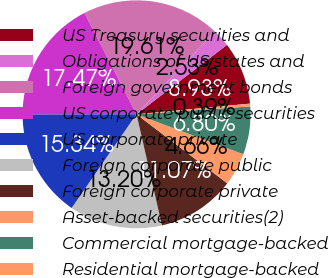Convert chart. <chart><loc_0><loc_0><loc_500><loc_500><pie_chart><fcel>US Treasury securities and<fcel>Obligations of US states and<fcel>Foreign government bonds<fcel>US corporate public securities<fcel>US corporate private<fcel>Foreign corporate public<fcel>Foreign corporate private<fcel>Asset-backed securities(2)<fcel>Commercial mortgage-backed<fcel>Residential mortgage-backed<nl><fcel>8.93%<fcel>2.53%<fcel>19.61%<fcel>17.47%<fcel>15.34%<fcel>13.2%<fcel>11.07%<fcel>4.66%<fcel>6.8%<fcel>0.39%<nl></chart> 